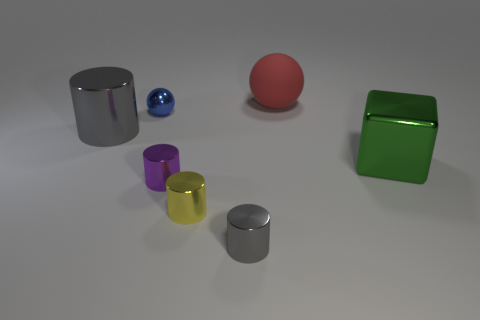There is a sphere left of the tiny gray metallic cylinder that is right of the tiny yellow shiny thing; what is its color? The sphere to the left of the tiny gray metallic cylinder, which in turn is to the right of the tiny yellow glossy object, appears to be red in color; it has a deep, vibrant hue reminiscent of a ripe cherry. 